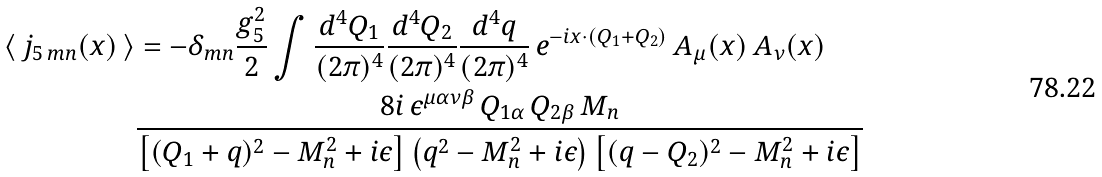Convert formula to latex. <formula><loc_0><loc_0><loc_500><loc_500>\langle \, j _ { 5 \, m n } ( x ) \, \rangle & = - \delta _ { m n } \frac { g _ { 5 } ^ { 2 } } { 2 } \int \frac { d ^ { 4 } Q _ { 1 } } { ( 2 \pi ) ^ { 4 } } \frac { d ^ { 4 } Q _ { 2 } } { ( 2 \pi ) ^ { 4 } } \frac { d ^ { 4 } q } { ( 2 \pi ) ^ { 4 } } \, e ^ { - i x \cdot ( Q _ { 1 } + Q _ { 2 } ) } \, A _ { \mu } ( x ) \, A _ { \nu } ( x ) \\ & \frac { 8 i \, \epsilon ^ { \mu \alpha \nu \beta } \, Q _ { 1 \alpha } \, Q _ { 2 \beta } \, M _ { n } } { \left [ ( Q _ { 1 } + q ) ^ { 2 } - M _ { n } ^ { 2 } + i \epsilon \right ] \left ( q ^ { 2 } - M _ { n } ^ { 2 } + i \epsilon \right ) \left [ ( q - Q _ { 2 } ) ^ { 2 } - M _ { n } ^ { 2 } + i \epsilon \right ] }</formula> 